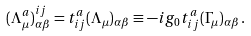<formula> <loc_0><loc_0><loc_500><loc_500>( \Lambda ^ { a } _ { \mu } ) ^ { i j } _ { \alpha \beta } = t ^ { a } _ { i j } ( \Lambda _ { \mu } ) _ { \alpha \beta } \equiv - i g _ { 0 } t ^ { a } _ { i j } ( \Gamma _ { \mu } ) _ { \alpha \beta } \, .</formula> 